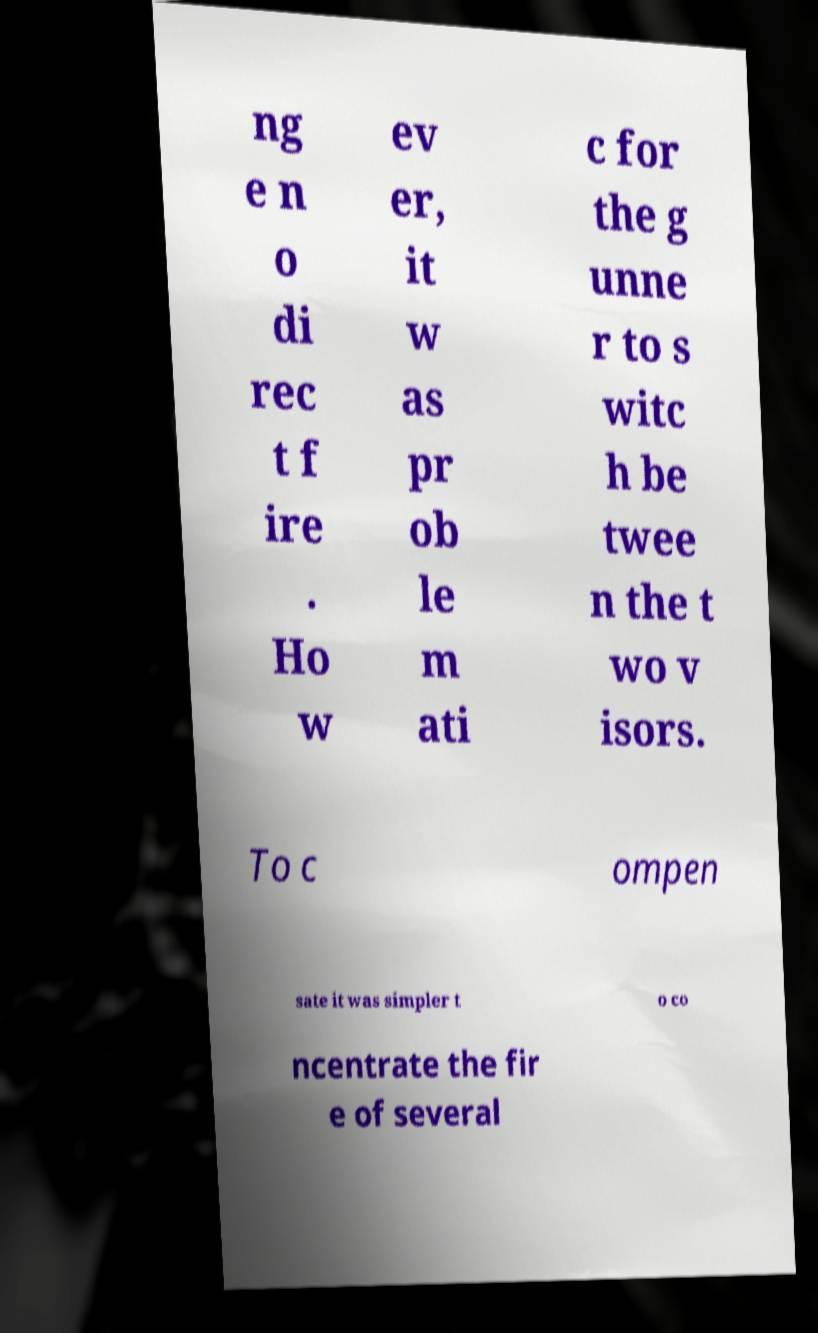For documentation purposes, I need the text within this image transcribed. Could you provide that? ng e n o di rec t f ire . Ho w ev er, it w as pr ob le m ati c for the g unne r to s witc h be twee n the t wo v isors. To c ompen sate it was simpler t o co ncentrate the fir e of several 